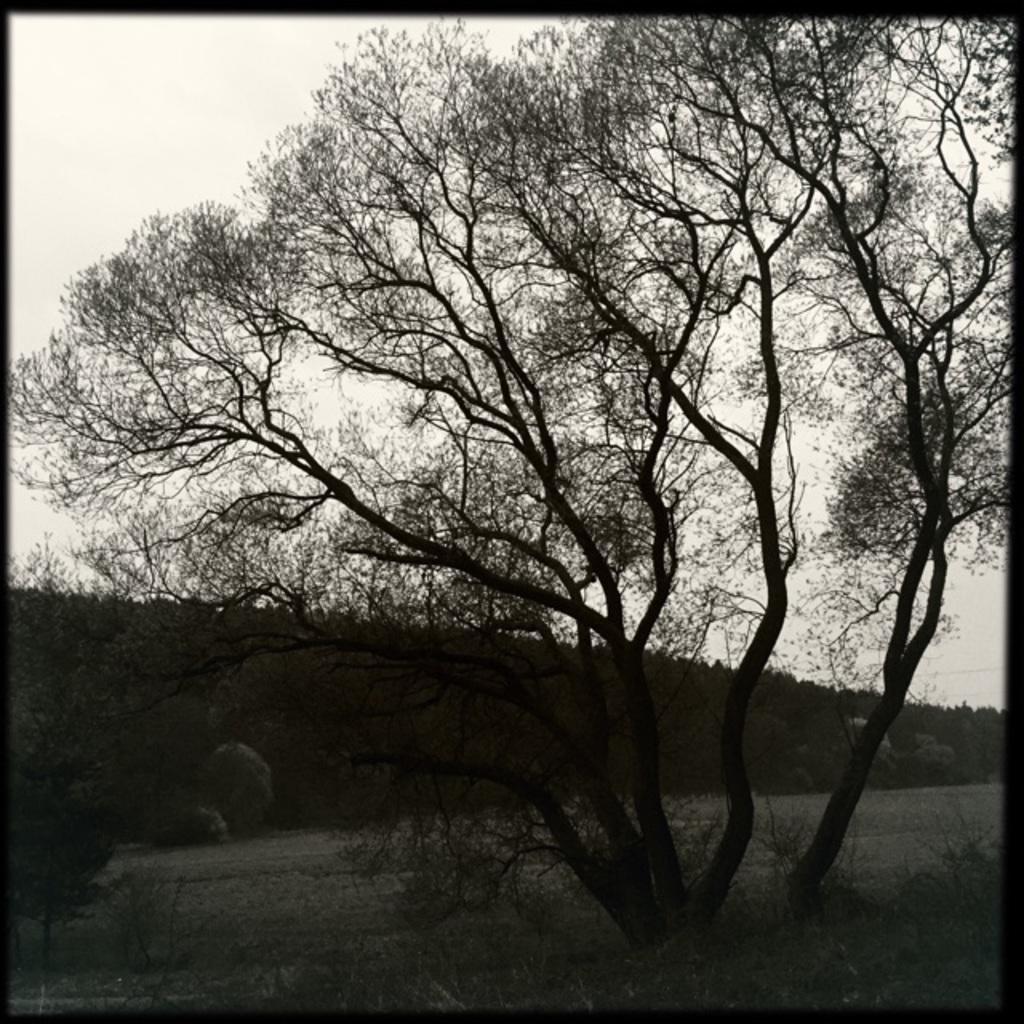Can you describe this image briefly? In this image there are trees, rocks, path, slope ground and the sky. 